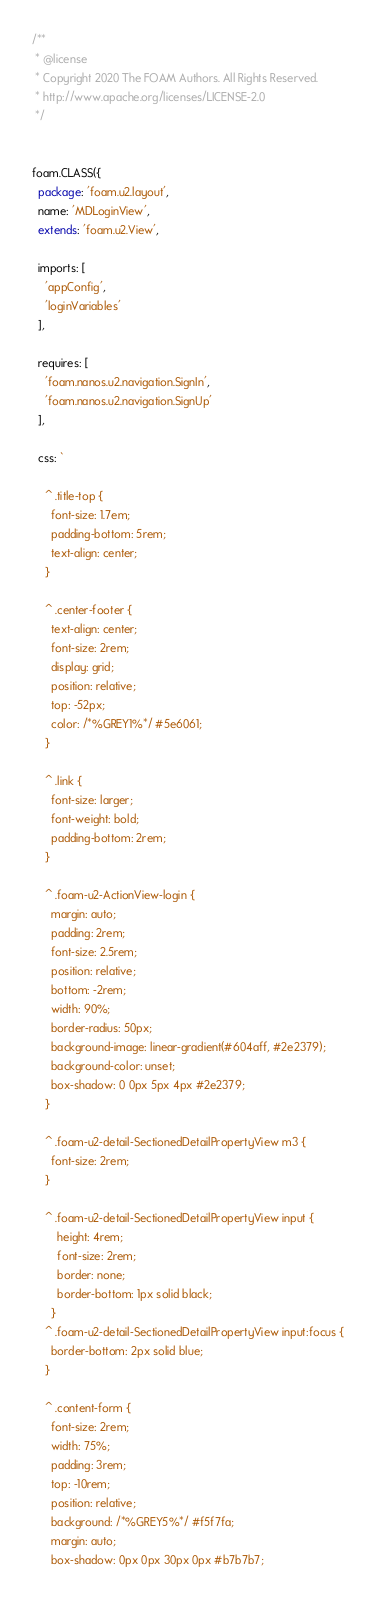Convert code to text. <code><loc_0><loc_0><loc_500><loc_500><_JavaScript_>/**
 * @license
 * Copyright 2020 The FOAM Authors. All Rights Reserved.
 * http://www.apache.org/licenses/LICENSE-2.0
 */


foam.CLASS({
  package: 'foam.u2.layout',
  name: 'MDLoginView',
  extends: 'foam.u2.View',

  imports: [
    'appConfig',
    'loginVariables'
  ],

  requires: [
    'foam.nanos.u2.navigation.SignIn',
    'foam.nanos.u2.navigation.SignUp'
  ],

  css: `

    ^ .title-top {
      font-size: 1.7em;
      padding-bottom: 5rem;
      text-align: center;
    }

    ^ .center-footer {
      text-align: center;
      font-size: 2rem;
      display: grid;
      position: relative;
      top: -52px;
      color: /*%GREY1%*/ #5e6061;
    }

    ^ .link {
      font-size: larger;
      font-weight: bold;
      padding-bottom: 2rem;
    }

    ^ .foam-u2-ActionView-login {
      margin: auto;
      padding: 2rem;
      font-size: 2.5rem;
      position: relative;
      bottom: -2rem;
      width: 90%;
      border-radius: 50px;
      background-image: linear-gradient(#604aff, #2e2379);
      background-color: unset;
      box-shadow: 0 0px 5px 4px #2e2379;
    }

    ^ .foam-u2-detail-SectionedDetailPropertyView m3 {
      font-size: 2rem;
    }

    ^ .foam-u2-detail-SectionedDetailPropertyView input {
        height: 4rem;
        font-size: 2rem;
        border: none;
        border-bottom: 1px solid black;
      }
    ^ .foam-u2-detail-SectionedDetailPropertyView input:focus {
      border-bottom: 2px solid blue;
    }

    ^ .content-form {
      font-size: 2rem;
      width: 75%;
      padding: 3rem;
      top: -10rem;
      position: relative;
      background: /*%GREY5%*/ #f5f7fa;
      margin: auto;
      box-shadow: 0px 0px 30px 0px #b7b7b7;</code> 